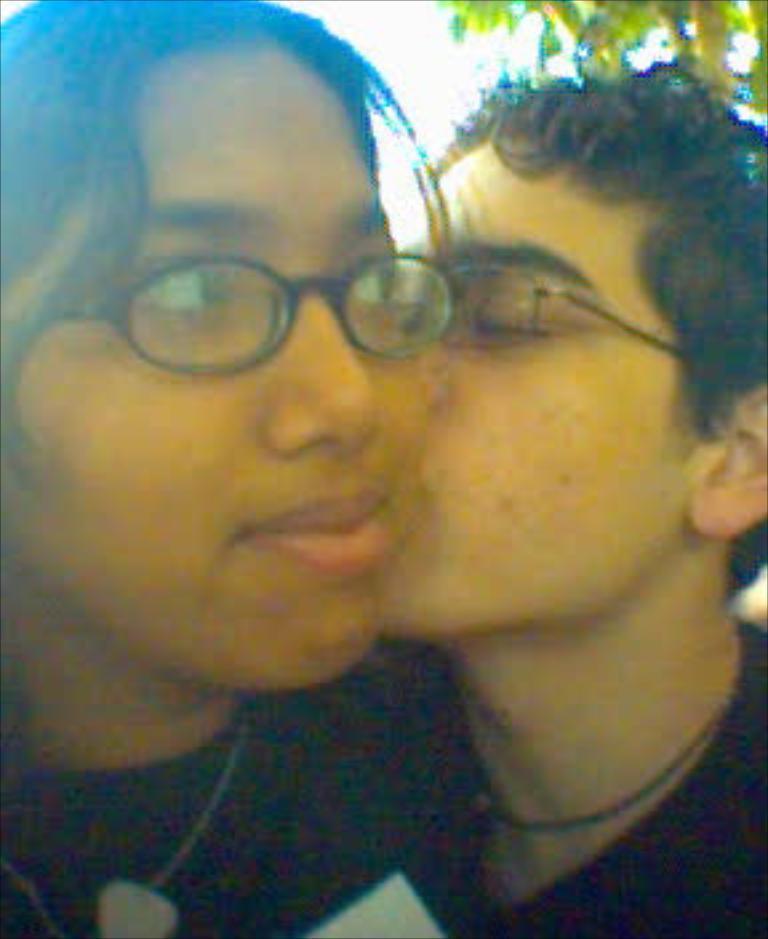Can you describe this image briefly? In this image a boy kissing a girl. 